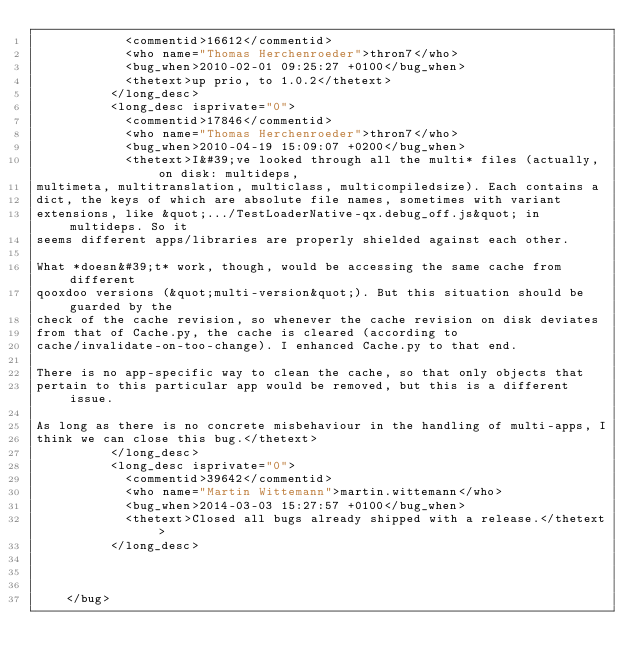<code> <loc_0><loc_0><loc_500><loc_500><_XML_>            <commentid>16612</commentid>
            <who name="Thomas Herchenroeder">thron7</who>
            <bug_when>2010-02-01 09:25:27 +0100</bug_when>
            <thetext>up prio, to 1.0.2</thetext>
          </long_desc>
          <long_desc isprivate="0">
            <commentid>17846</commentid>
            <who name="Thomas Herchenroeder">thron7</who>
            <bug_when>2010-04-19 15:09:07 +0200</bug_when>
            <thetext>I&#39;ve looked through all the multi* files (actually, on disk: multideps, 
multimeta, multitranslation, multiclass, multicompiledsize). Each contains a 
dict, the keys of which are absolute file names, sometimes with variant 
extensions, like &quot;.../TestLoaderNative-qx.debug_off.js&quot; in multideps. So it 
seems different apps/libraries are properly shielded against each other.

What *doesn&#39;t* work, though, would be accessing the same cache from different 
qooxdoo versions (&quot;multi-version&quot;). But this situation should be guarded by the 
check of the cache revision, so whenever the cache revision on disk deviates 
from that of Cache.py, the cache is cleared (according to 
cache/invalidate-on-too-change). I enhanced Cache.py to that end.

There is no app-specific way to clean the cache, so that only objects that 
pertain to this particular app would be removed, but this is a different issue.

As long as there is no concrete misbehaviour in the handling of multi-apps, I 
think we can close this bug.</thetext>
          </long_desc>
          <long_desc isprivate="0">
            <commentid>39642</commentid>
            <who name="Martin Wittemann">martin.wittemann</who>
            <bug_when>2014-03-03 15:27:57 +0100</bug_when>
            <thetext>Closed all bugs already shipped with a release.</thetext>
          </long_desc>
      
      

    </bug></code> 